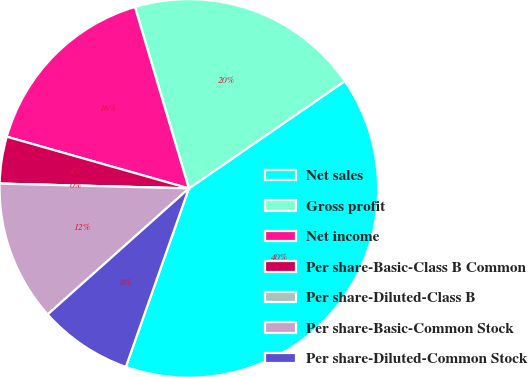Convert chart to OTSL. <chart><loc_0><loc_0><loc_500><loc_500><pie_chart><fcel>Net sales<fcel>Gross profit<fcel>Net income<fcel>Per share-Basic-Class B Common<fcel>Per share-Diluted-Class B<fcel>Per share-Basic-Common Stock<fcel>Per share-Diluted-Common Stock<nl><fcel>40.0%<fcel>20.0%<fcel>16.0%<fcel>4.0%<fcel>0.0%<fcel>12.0%<fcel>8.0%<nl></chart> 